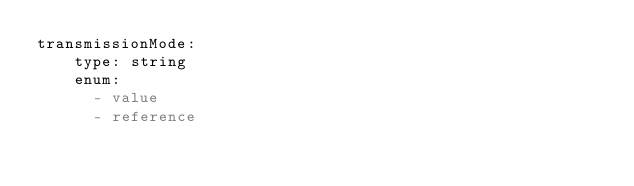<code> <loc_0><loc_0><loc_500><loc_500><_YAML_>transmissionMode:
    type: string
    enum:
      - value
      - reference</code> 